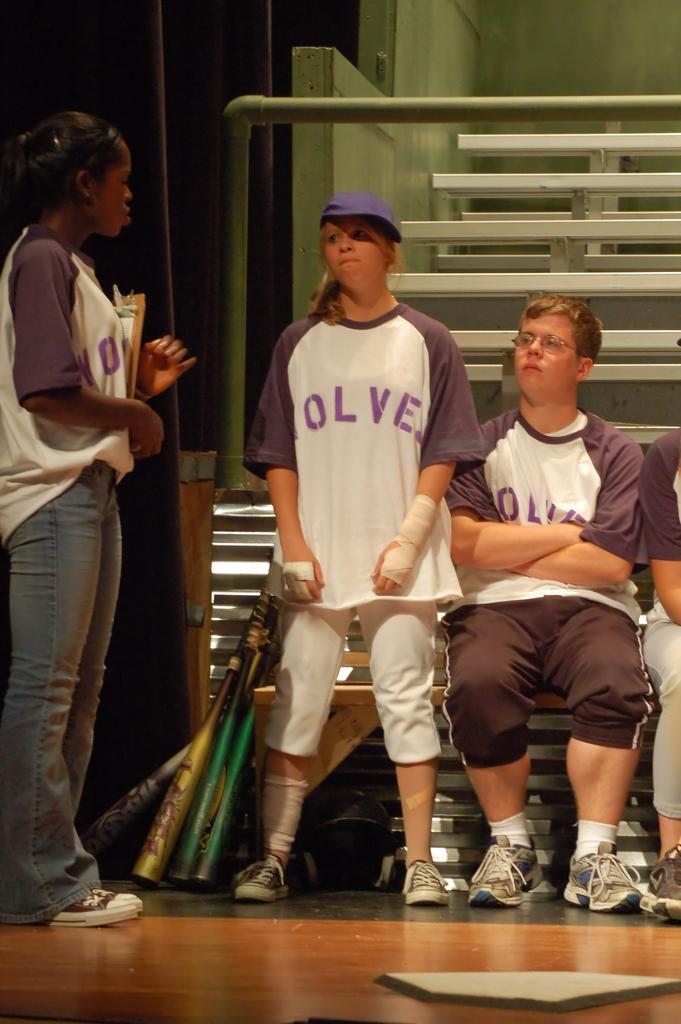<image>
Give a short and clear explanation of the subsequent image. young people standing on a stage in Wolves baseball jerseys 